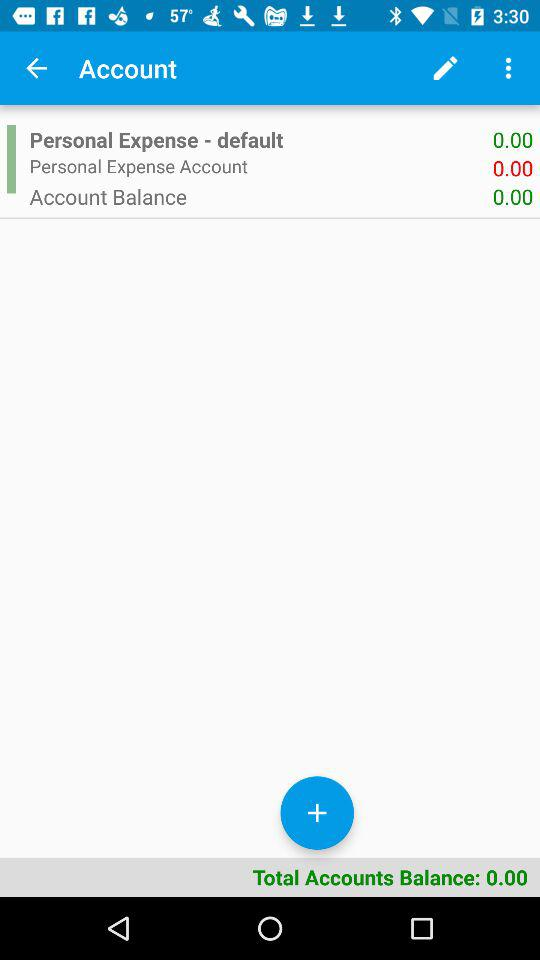When was the last transaction made?
When the provided information is insufficient, respond with <no answer>. <no answer> 